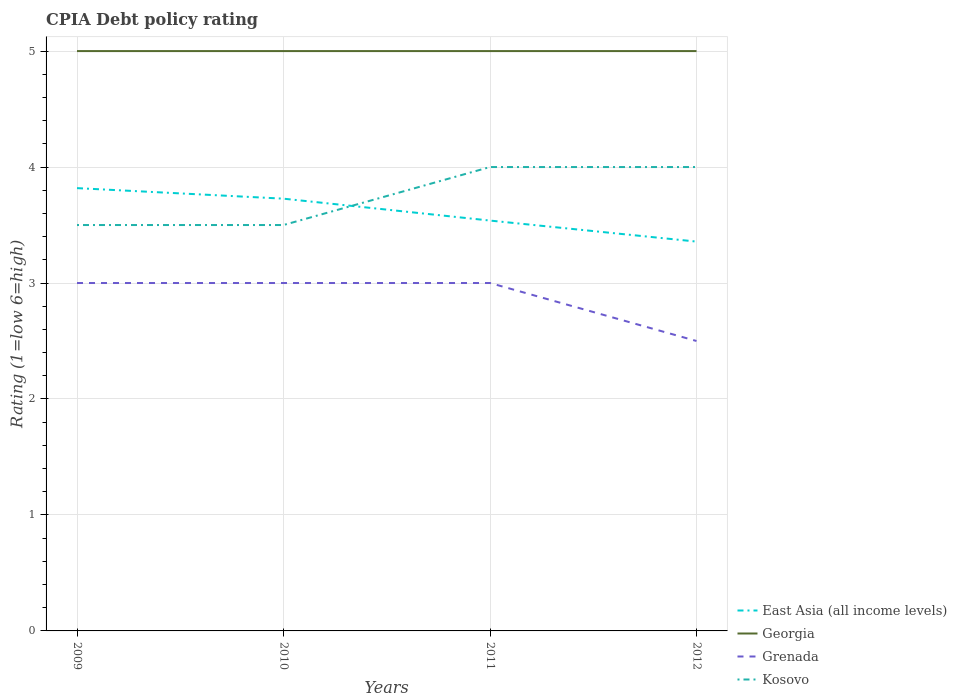How many different coloured lines are there?
Your answer should be compact. 4. Across all years, what is the maximum CPIA rating in Kosovo?
Offer a terse response. 3.5. In which year was the CPIA rating in Grenada maximum?
Offer a very short reply. 2012. How many years are there in the graph?
Provide a short and direct response. 4. What is the difference between two consecutive major ticks on the Y-axis?
Offer a terse response. 1. Are the values on the major ticks of Y-axis written in scientific E-notation?
Provide a succinct answer. No. Does the graph contain any zero values?
Offer a very short reply. No. Does the graph contain grids?
Your response must be concise. Yes. Where does the legend appear in the graph?
Make the answer very short. Bottom right. How are the legend labels stacked?
Give a very brief answer. Vertical. What is the title of the graph?
Provide a succinct answer. CPIA Debt policy rating. Does "Switzerland" appear as one of the legend labels in the graph?
Your response must be concise. No. What is the Rating (1=low 6=high) of East Asia (all income levels) in 2009?
Make the answer very short. 3.82. What is the Rating (1=low 6=high) of Grenada in 2009?
Make the answer very short. 3. What is the Rating (1=low 6=high) of East Asia (all income levels) in 2010?
Offer a terse response. 3.73. What is the Rating (1=low 6=high) of Grenada in 2010?
Offer a terse response. 3. What is the Rating (1=low 6=high) of Kosovo in 2010?
Ensure brevity in your answer.  3.5. What is the Rating (1=low 6=high) in East Asia (all income levels) in 2011?
Ensure brevity in your answer.  3.54. What is the Rating (1=low 6=high) in Grenada in 2011?
Keep it short and to the point. 3. What is the Rating (1=low 6=high) in Kosovo in 2011?
Your answer should be very brief. 4. What is the Rating (1=low 6=high) of East Asia (all income levels) in 2012?
Provide a succinct answer. 3.36. What is the Rating (1=low 6=high) of Grenada in 2012?
Offer a very short reply. 2.5. Across all years, what is the maximum Rating (1=low 6=high) of East Asia (all income levels)?
Provide a succinct answer. 3.82. Across all years, what is the maximum Rating (1=low 6=high) in Grenada?
Offer a terse response. 3. Across all years, what is the minimum Rating (1=low 6=high) of East Asia (all income levels)?
Offer a terse response. 3.36. Across all years, what is the minimum Rating (1=low 6=high) in Georgia?
Your response must be concise. 5. Across all years, what is the minimum Rating (1=low 6=high) of Grenada?
Provide a succinct answer. 2.5. What is the total Rating (1=low 6=high) of East Asia (all income levels) in the graph?
Ensure brevity in your answer.  14.44. What is the total Rating (1=low 6=high) of Georgia in the graph?
Give a very brief answer. 20. What is the total Rating (1=low 6=high) in Grenada in the graph?
Give a very brief answer. 11.5. What is the difference between the Rating (1=low 6=high) in East Asia (all income levels) in 2009 and that in 2010?
Provide a short and direct response. 0.09. What is the difference between the Rating (1=low 6=high) in Georgia in 2009 and that in 2010?
Give a very brief answer. 0. What is the difference between the Rating (1=low 6=high) of Grenada in 2009 and that in 2010?
Offer a terse response. 0. What is the difference between the Rating (1=low 6=high) in East Asia (all income levels) in 2009 and that in 2011?
Keep it short and to the point. 0.28. What is the difference between the Rating (1=low 6=high) in Grenada in 2009 and that in 2011?
Keep it short and to the point. 0. What is the difference between the Rating (1=low 6=high) of East Asia (all income levels) in 2009 and that in 2012?
Keep it short and to the point. 0.46. What is the difference between the Rating (1=low 6=high) in Georgia in 2009 and that in 2012?
Offer a very short reply. 0. What is the difference between the Rating (1=low 6=high) of Grenada in 2009 and that in 2012?
Provide a short and direct response. 0.5. What is the difference between the Rating (1=low 6=high) of East Asia (all income levels) in 2010 and that in 2011?
Give a very brief answer. 0.19. What is the difference between the Rating (1=low 6=high) of Georgia in 2010 and that in 2011?
Give a very brief answer. 0. What is the difference between the Rating (1=low 6=high) of Kosovo in 2010 and that in 2011?
Offer a terse response. -0.5. What is the difference between the Rating (1=low 6=high) of East Asia (all income levels) in 2010 and that in 2012?
Provide a short and direct response. 0.37. What is the difference between the Rating (1=low 6=high) in Grenada in 2010 and that in 2012?
Your answer should be very brief. 0.5. What is the difference between the Rating (1=low 6=high) in East Asia (all income levels) in 2011 and that in 2012?
Your answer should be very brief. 0.18. What is the difference between the Rating (1=low 6=high) of Georgia in 2011 and that in 2012?
Offer a very short reply. 0. What is the difference between the Rating (1=low 6=high) in Grenada in 2011 and that in 2012?
Your answer should be very brief. 0.5. What is the difference between the Rating (1=low 6=high) in East Asia (all income levels) in 2009 and the Rating (1=low 6=high) in Georgia in 2010?
Your answer should be compact. -1.18. What is the difference between the Rating (1=low 6=high) of East Asia (all income levels) in 2009 and the Rating (1=low 6=high) of Grenada in 2010?
Ensure brevity in your answer.  0.82. What is the difference between the Rating (1=low 6=high) of East Asia (all income levels) in 2009 and the Rating (1=low 6=high) of Kosovo in 2010?
Offer a very short reply. 0.32. What is the difference between the Rating (1=low 6=high) in Georgia in 2009 and the Rating (1=low 6=high) in Grenada in 2010?
Give a very brief answer. 2. What is the difference between the Rating (1=low 6=high) of Grenada in 2009 and the Rating (1=low 6=high) of Kosovo in 2010?
Provide a short and direct response. -0.5. What is the difference between the Rating (1=low 6=high) in East Asia (all income levels) in 2009 and the Rating (1=low 6=high) in Georgia in 2011?
Ensure brevity in your answer.  -1.18. What is the difference between the Rating (1=low 6=high) in East Asia (all income levels) in 2009 and the Rating (1=low 6=high) in Grenada in 2011?
Your answer should be compact. 0.82. What is the difference between the Rating (1=low 6=high) in East Asia (all income levels) in 2009 and the Rating (1=low 6=high) in Kosovo in 2011?
Offer a terse response. -0.18. What is the difference between the Rating (1=low 6=high) in East Asia (all income levels) in 2009 and the Rating (1=low 6=high) in Georgia in 2012?
Your response must be concise. -1.18. What is the difference between the Rating (1=low 6=high) in East Asia (all income levels) in 2009 and the Rating (1=low 6=high) in Grenada in 2012?
Offer a terse response. 1.32. What is the difference between the Rating (1=low 6=high) in East Asia (all income levels) in 2009 and the Rating (1=low 6=high) in Kosovo in 2012?
Offer a terse response. -0.18. What is the difference between the Rating (1=low 6=high) of Georgia in 2009 and the Rating (1=low 6=high) of Grenada in 2012?
Your answer should be very brief. 2.5. What is the difference between the Rating (1=low 6=high) of Georgia in 2009 and the Rating (1=low 6=high) of Kosovo in 2012?
Your answer should be compact. 1. What is the difference between the Rating (1=low 6=high) of Grenada in 2009 and the Rating (1=low 6=high) of Kosovo in 2012?
Offer a very short reply. -1. What is the difference between the Rating (1=low 6=high) of East Asia (all income levels) in 2010 and the Rating (1=low 6=high) of Georgia in 2011?
Give a very brief answer. -1.27. What is the difference between the Rating (1=low 6=high) of East Asia (all income levels) in 2010 and the Rating (1=low 6=high) of Grenada in 2011?
Ensure brevity in your answer.  0.73. What is the difference between the Rating (1=low 6=high) in East Asia (all income levels) in 2010 and the Rating (1=low 6=high) in Kosovo in 2011?
Offer a terse response. -0.27. What is the difference between the Rating (1=low 6=high) in Georgia in 2010 and the Rating (1=low 6=high) in Grenada in 2011?
Give a very brief answer. 2. What is the difference between the Rating (1=low 6=high) of Georgia in 2010 and the Rating (1=low 6=high) of Kosovo in 2011?
Provide a short and direct response. 1. What is the difference between the Rating (1=low 6=high) of East Asia (all income levels) in 2010 and the Rating (1=low 6=high) of Georgia in 2012?
Ensure brevity in your answer.  -1.27. What is the difference between the Rating (1=low 6=high) in East Asia (all income levels) in 2010 and the Rating (1=low 6=high) in Grenada in 2012?
Keep it short and to the point. 1.23. What is the difference between the Rating (1=low 6=high) of East Asia (all income levels) in 2010 and the Rating (1=low 6=high) of Kosovo in 2012?
Provide a succinct answer. -0.27. What is the difference between the Rating (1=low 6=high) in Georgia in 2010 and the Rating (1=low 6=high) in Grenada in 2012?
Make the answer very short. 2.5. What is the difference between the Rating (1=low 6=high) of Georgia in 2010 and the Rating (1=low 6=high) of Kosovo in 2012?
Offer a very short reply. 1. What is the difference between the Rating (1=low 6=high) in East Asia (all income levels) in 2011 and the Rating (1=low 6=high) in Georgia in 2012?
Give a very brief answer. -1.46. What is the difference between the Rating (1=low 6=high) of East Asia (all income levels) in 2011 and the Rating (1=low 6=high) of Grenada in 2012?
Give a very brief answer. 1.04. What is the difference between the Rating (1=low 6=high) in East Asia (all income levels) in 2011 and the Rating (1=low 6=high) in Kosovo in 2012?
Provide a succinct answer. -0.46. What is the difference between the Rating (1=low 6=high) of Georgia in 2011 and the Rating (1=low 6=high) of Kosovo in 2012?
Keep it short and to the point. 1. What is the average Rating (1=low 6=high) in East Asia (all income levels) per year?
Ensure brevity in your answer.  3.61. What is the average Rating (1=low 6=high) of Grenada per year?
Offer a very short reply. 2.88. What is the average Rating (1=low 6=high) in Kosovo per year?
Your answer should be compact. 3.75. In the year 2009, what is the difference between the Rating (1=low 6=high) in East Asia (all income levels) and Rating (1=low 6=high) in Georgia?
Ensure brevity in your answer.  -1.18. In the year 2009, what is the difference between the Rating (1=low 6=high) of East Asia (all income levels) and Rating (1=low 6=high) of Grenada?
Provide a short and direct response. 0.82. In the year 2009, what is the difference between the Rating (1=low 6=high) of East Asia (all income levels) and Rating (1=low 6=high) of Kosovo?
Offer a terse response. 0.32. In the year 2009, what is the difference between the Rating (1=low 6=high) in Georgia and Rating (1=low 6=high) in Grenada?
Your answer should be compact. 2. In the year 2009, what is the difference between the Rating (1=low 6=high) in Georgia and Rating (1=low 6=high) in Kosovo?
Ensure brevity in your answer.  1.5. In the year 2009, what is the difference between the Rating (1=low 6=high) in Grenada and Rating (1=low 6=high) in Kosovo?
Offer a very short reply. -0.5. In the year 2010, what is the difference between the Rating (1=low 6=high) in East Asia (all income levels) and Rating (1=low 6=high) in Georgia?
Provide a succinct answer. -1.27. In the year 2010, what is the difference between the Rating (1=low 6=high) of East Asia (all income levels) and Rating (1=low 6=high) of Grenada?
Give a very brief answer. 0.73. In the year 2010, what is the difference between the Rating (1=low 6=high) in East Asia (all income levels) and Rating (1=low 6=high) in Kosovo?
Offer a terse response. 0.23. In the year 2010, what is the difference between the Rating (1=low 6=high) of Georgia and Rating (1=low 6=high) of Grenada?
Provide a short and direct response. 2. In the year 2011, what is the difference between the Rating (1=low 6=high) in East Asia (all income levels) and Rating (1=low 6=high) in Georgia?
Make the answer very short. -1.46. In the year 2011, what is the difference between the Rating (1=low 6=high) in East Asia (all income levels) and Rating (1=low 6=high) in Grenada?
Make the answer very short. 0.54. In the year 2011, what is the difference between the Rating (1=low 6=high) in East Asia (all income levels) and Rating (1=low 6=high) in Kosovo?
Make the answer very short. -0.46. In the year 2011, what is the difference between the Rating (1=low 6=high) in Georgia and Rating (1=low 6=high) in Grenada?
Keep it short and to the point. 2. In the year 2012, what is the difference between the Rating (1=low 6=high) in East Asia (all income levels) and Rating (1=low 6=high) in Georgia?
Provide a succinct answer. -1.64. In the year 2012, what is the difference between the Rating (1=low 6=high) in East Asia (all income levels) and Rating (1=low 6=high) in Grenada?
Ensure brevity in your answer.  0.86. In the year 2012, what is the difference between the Rating (1=low 6=high) in East Asia (all income levels) and Rating (1=low 6=high) in Kosovo?
Ensure brevity in your answer.  -0.64. In the year 2012, what is the difference between the Rating (1=low 6=high) of Grenada and Rating (1=low 6=high) of Kosovo?
Ensure brevity in your answer.  -1.5. What is the ratio of the Rating (1=low 6=high) in East Asia (all income levels) in 2009 to that in 2010?
Your answer should be very brief. 1.02. What is the ratio of the Rating (1=low 6=high) in Georgia in 2009 to that in 2010?
Provide a succinct answer. 1. What is the ratio of the Rating (1=low 6=high) of Kosovo in 2009 to that in 2010?
Keep it short and to the point. 1. What is the ratio of the Rating (1=low 6=high) of East Asia (all income levels) in 2009 to that in 2011?
Ensure brevity in your answer.  1.08. What is the ratio of the Rating (1=low 6=high) in Georgia in 2009 to that in 2011?
Offer a very short reply. 1. What is the ratio of the Rating (1=low 6=high) of Grenada in 2009 to that in 2011?
Offer a very short reply. 1. What is the ratio of the Rating (1=low 6=high) in Kosovo in 2009 to that in 2011?
Your answer should be compact. 0.88. What is the ratio of the Rating (1=low 6=high) in East Asia (all income levels) in 2009 to that in 2012?
Make the answer very short. 1.14. What is the ratio of the Rating (1=low 6=high) of Georgia in 2009 to that in 2012?
Give a very brief answer. 1. What is the ratio of the Rating (1=low 6=high) in Kosovo in 2009 to that in 2012?
Offer a terse response. 0.88. What is the ratio of the Rating (1=low 6=high) in East Asia (all income levels) in 2010 to that in 2011?
Give a very brief answer. 1.05. What is the ratio of the Rating (1=low 6=high) of Kosovo in 2010 to that in 2011?
Offer a terse response. 0.88. What is the ratio of the Rating (1=low 6=high) in East Asia (all income levels) in 2010 to that in 2012?
Provide a succinct answer. 1.11. What is the ratio of the Rating (1=low 6=high) in Kosovo in 2010 to that in 2012?
Give a very brief answer. 0.88. What is the ratio of the Rating (1=low 6=high) of East Asia (all income levels) in 2011 to that in 2012?
Make the answer very short. 1.05. What is the ratio of the Rating (1=low 6=high) of Georgia in 2011 to that in 2012?
Give a very brief answer. 1. What is the ratio of the Rating (1=low 6=high) of Grenada in 2011 to that in 2012?
Provide a short and direct response. 1.2. What is the difference between the highest and the second highest Rating (1=low 6=high) of East Asia (all income levels)?
Provide a succinct answer. 0.09. What is the difference between the highest and the second highest Rating (1=low 6=high) in Georgia?
Your response must be concise. 0. What is the difference between the highest and the second highest Rating (1=low 6=high) in Grenada?
Offer a very short reply. 0. What is the difference between the highest and the lowest Rating (1=low 6=high) in East Asia (all income levels)?
Your answer should be very brief. 0.46. What is the difference between the highest and the lowest Rating (1=low 6=high) in Kosovo?
Give a very brief answer. 0.5. 